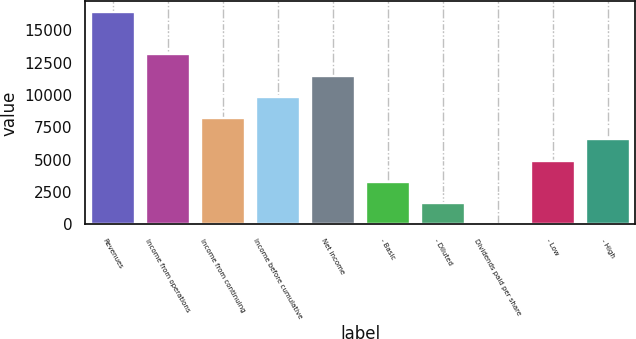Convert chart. <chart><loc_0><loc_0><loc_500><loc_500><bar_chart><fcel>Revenues<fcel>Income from operations<fcel>Income from continuing<fcel>Income before cumulative<fcel>Net income<fcel>- Basic<fcel>- Diluted<fcel>Dividends paid per share<fcel>- Low<fcel>- High<nl><fcel>16418<fcel>13134.5<fcel>8209.18<fcel>9850.95<fcel>11492.7<fcel>3283.87<fcel>1642.1<fcel>0.33<fcel>4925.64<fcel>6567.41<nl></chart> 